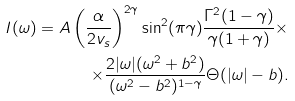Convert formula to latex. <formula><loc_0><loc_0><loc_500><loc_500>I ( \omega ) = A \left ( \frac { \alpha } { 2 v _ { s } } \right ) ^ { 2 \gamma } \sin ^ { 2 } ( \pi \gamma ) \frac { \Gamma ^ { 2 } ( 1 - \gamma ) } { \gamma ( 1 + \gamma ) } \times \\ \times \frac { 2 | \omega | ( \omega ^ { 2 } + b ^ { 2 } ) } { ( \omega ^ { 2 } - b ^ { 2 } ) ^ { 1 - \gamma } } \Theta ( | \omega | - b ) .</formula> 